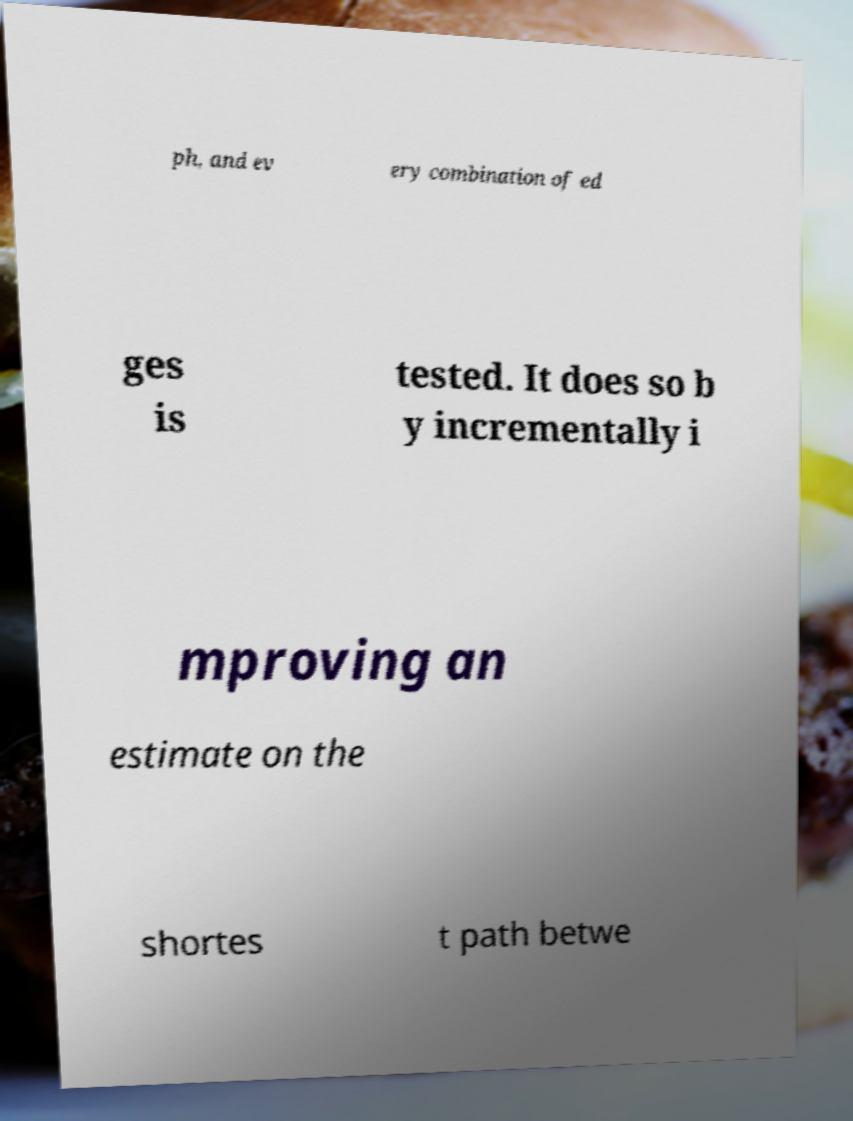I need the written content from this picture converted into text. Can you do that? ph, and ev ery combination of ed ges is tested. It does so b y incrementally i mproving an estimate on the shortes t path betwe 